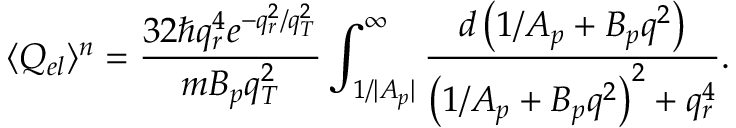<formula> <loc_0><loc_0><loc_500><loc_500>\langle Q _ { e l } \rangle ^ { n } = \frac { 3 2 \hbar { q } _ { r } ^ { 4 } e ^ { - q _ { r } ^ { 2 } / q _ { T } ^ { 2 } } } { m B _ { p } q _ { T } ^ { 2 } } \int _ { 1 / { | A _ { p } | } } ^ { \infty } { \frac { d \left ( 1 / A _ { p } + B _ { p } q ^ { 2 } \right ) } { { \left ( 1 / A _ { p } + B _ { p } q ^ { 2 } \right ) } ^ { 2 } + q _ { r } ^ { 4 } } } .</formula> 